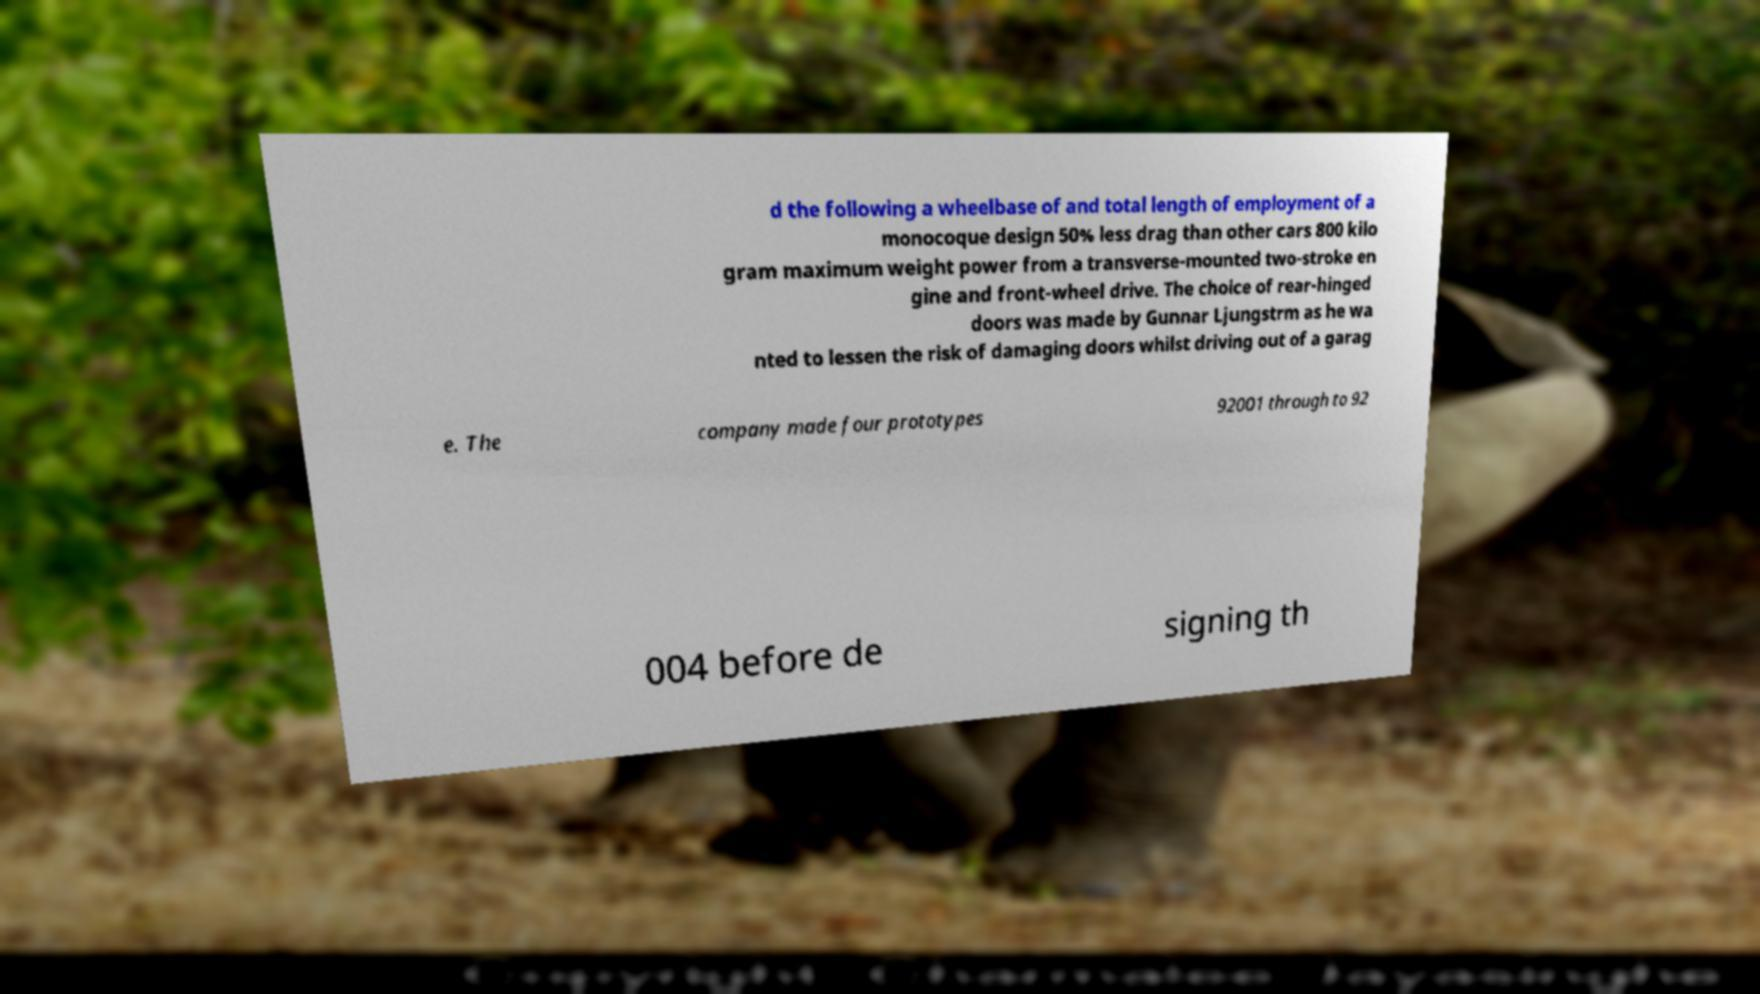Please read and relay the text visible in this image. What does it say? d the following a wheelbase of and total length of employment of a monocoque design 50% less drag than other cars 800 kilo gram maximum weight power from a transverse-mounted two-stroke en gine and front-wheel drive. The choice of rear-hinged doors was made by Gunnar Ljungstrm as he wa nted to lessen the risk of damaging doors whilst driving out of a garag e. The company made four prototypes 92001 through to 92 004 before de signing th 